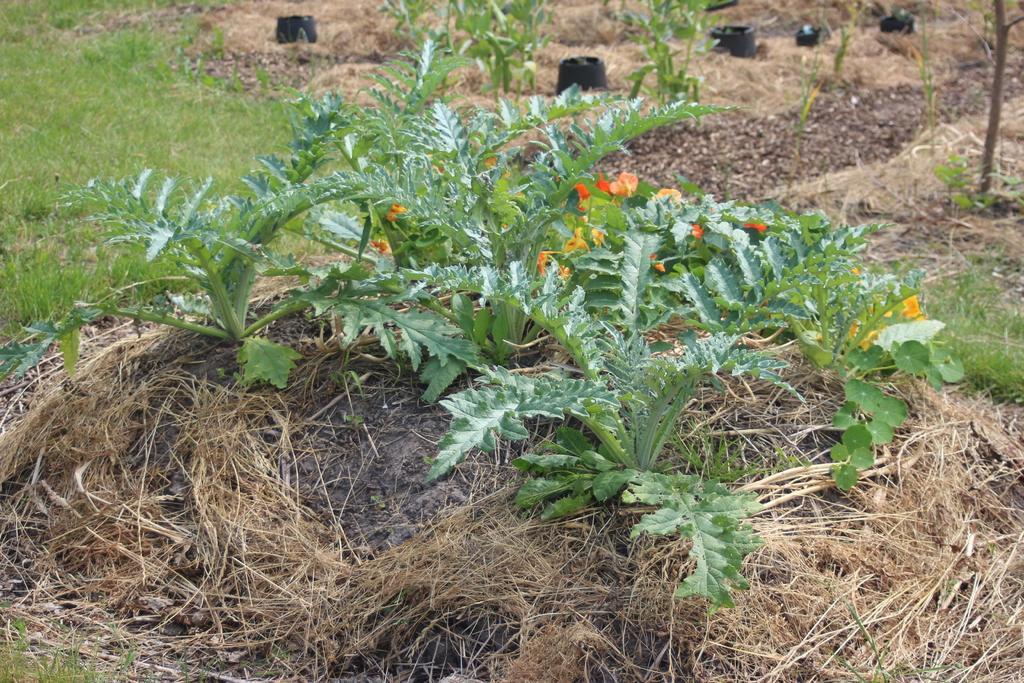Could you give a brief overview of what you see in this image? In the picture I can see the flowering plants and green leaves. I can see the grass at the bottom of the picture. I can see the green grass on the top left side of the picture. I can see the black color objects at the top of the picture. 